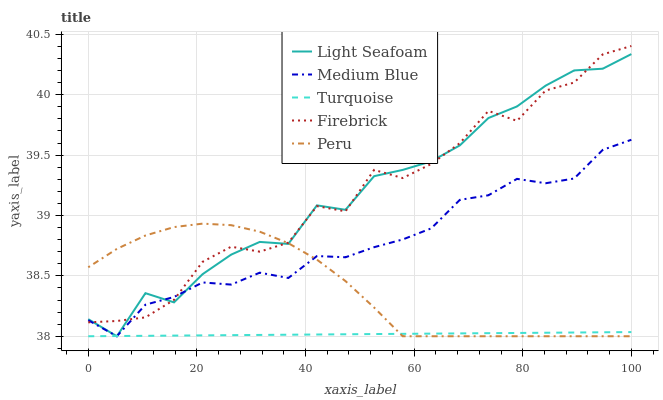Does Turquoise have the minimum area under the curve?
Answer yes or no. Yes. Does Light Seafoam have the maximum area under the curve?
Answer yes or no. Yes. Does Medium Blue have the minimum area under the curve?
Answer yes or no. No. Does Medium Blue have the maximum area under the curve?
Answer yes or no. No. Is Turquoise the smoothest?
Answer yes or no. Yes. Is Firebrick the roughest?
Answer yes or no. Yes. Is Light Seafoam the smoothest?
Answer yes or no. No. Is Light Seafoam the roughest?
Answer yes or no. No. Does Turquoise have the lowest value?
Answer yes or no. Yes. Does Firebrick have the lowest value?
Answer yes or no. No. Does Firebrick have the highest value?
Answer yes or no. Yes. Does Light Seafoam have the highest value?
Answer yes or no. No. Is Turquoise less than Firebrick?
Answer yes or no. Yes. Is Firebrick greater than Turquoise?
Answer yes or no. Yes. Does Medium Blue intersect Light Seafoam?
Answer yes or no. Yes. Is Medium Blue less than Light Seafoam?
Answer yes or no. No. Is Medium Blue greater than Light Seafoam?
Answer yes or no. No. Does Turquoise intersect Firebrick?
Answer yes or no. No. 